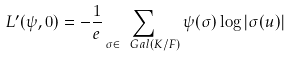Convert formula to latex. <formula><loc_0><loc_0><loc_500><loc_500>L ^ { \prime } ( \psi , 0 ) = - \frac { 1 } { e } \sum _ { \sigma \in \ G a l ( K / F ) } \psi ( \sigma ) \log | \sigma ( u ) |</formula> 